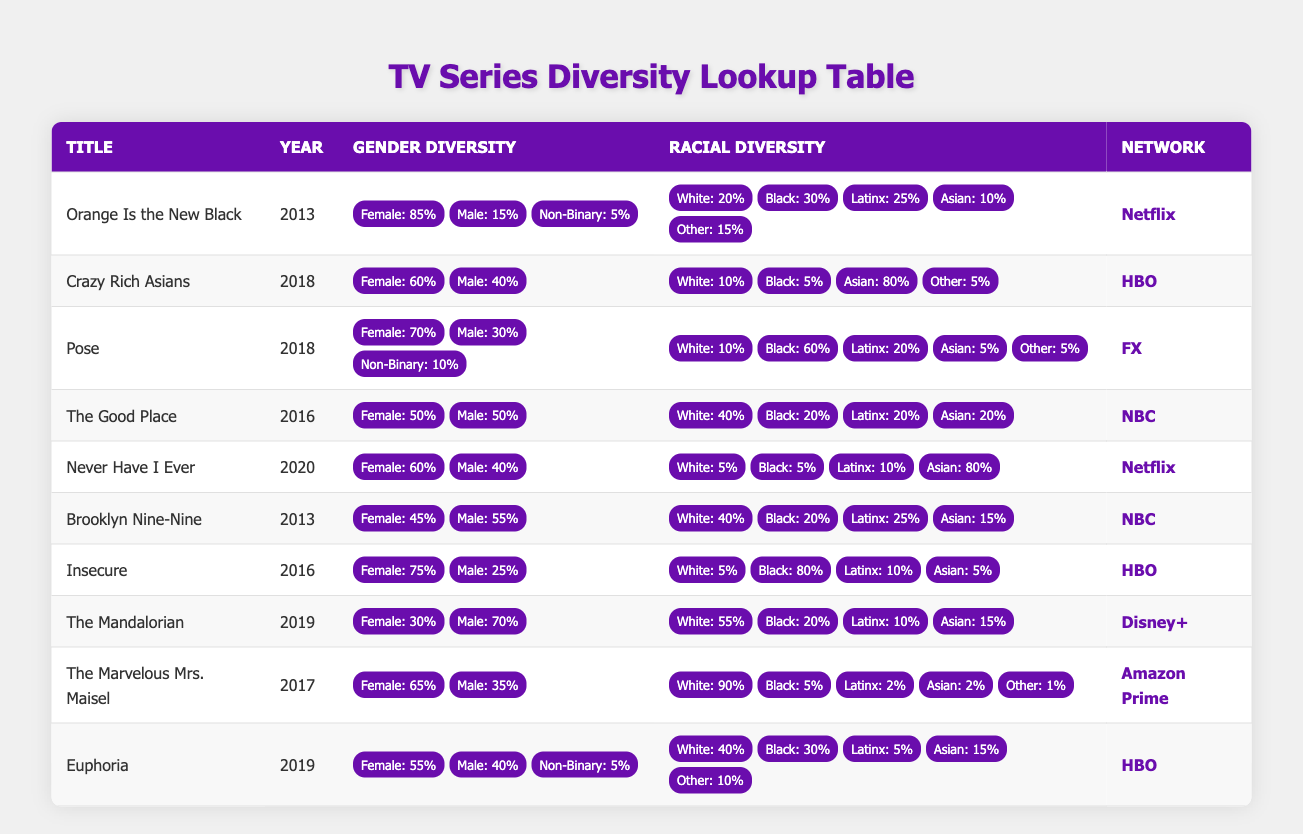What is the gender diversity percentage of "Pose"? The table states that "Pose" has 70% Female, 30% Male, and 10% Non-Binary. Thus, to obtain the total gender diversity percentage for "Pose," we see it is primarily Female.
Answer: 70% Female Which TV series has the highest percentage of Black representation? In the table, analyzing the racial diversity for each series, "Insecure" shows 80% Black representation, which is the highest among the listed titles.
Answer: Insecure (80% Black) What is the average percentage of Male actors across all listed series? To find the average Male representation, sum the Male percentages of all series: 15 + 40 + 30 + 50 + 40 + 55 + 25 + 70 + 35 + 40 =  450. There are 10 series listed, so the average is 450/10 = 45%.
Answer: 45% Does "The Good Place" have a higher percentage of White characters than "Orange Is the New Black"? "The Good Place" has 40% White representation, while "Orange Is the New Black" has only 20% White representation. Therefore, "The Good Place" does have a higher percentage.
Answer: Yes Which TV series showcases the least gender diversity among the Male and Non-Binary categories? Analyzing the data, "Crazy Rich Asians" has 40% Male and 0% Non-Binary, while other series exhibit at least a small percentage of Non-Binary diversity. Therefore, "Crazy Rich Asians" stands out for the least diverse representation.
Answer: Crazy Rich Asians What percentage of actors in "Euphoria" are Non-Binary? The table indicates that "Euphoria" has 5% Non-Binary actors, making that a straightforward retrieval of data from the series' gender diversity section.
Answer: 5% How many series have a Female representation of 60% or more? From the data, the series with Female representation above 60% are "Orange Is the New Black" (85%), "Pose" (70%), "Insecure" (75%), "Never Have I Ever" (60%), and "The Marvelous Mrs. Maisel" (65%). Counting these gives a total of 5 series.
Answer: 5 series 